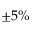Convert formula to latex. <formula><loc_0><loc_0><loc_500><loc_500>\pm 5 \%</formula> 